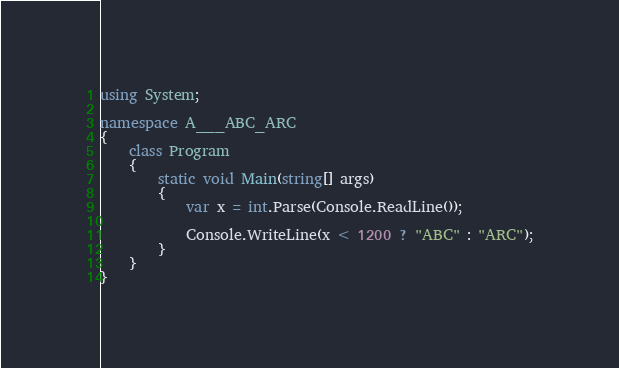<code> <loc_0><loc_0><loc_500><loc_500><_C#_>using System;

namespace A___ABC_ARC
{
    class Program
    {
        static void Main(string[] args)
        {
            var x = int.Parse(Console.ReadLine());

            Console.WriteLine(x < 1200 ? "ABC" : "ARC");
        }
    }
}
</code> 